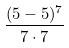Convert formula to latex. <formula><loc_0><loc_0><loc_500><loc_500>\frac { ( 5 - 5 ) ^ { 7 } } { 7 \cdot 7 }</formula> 